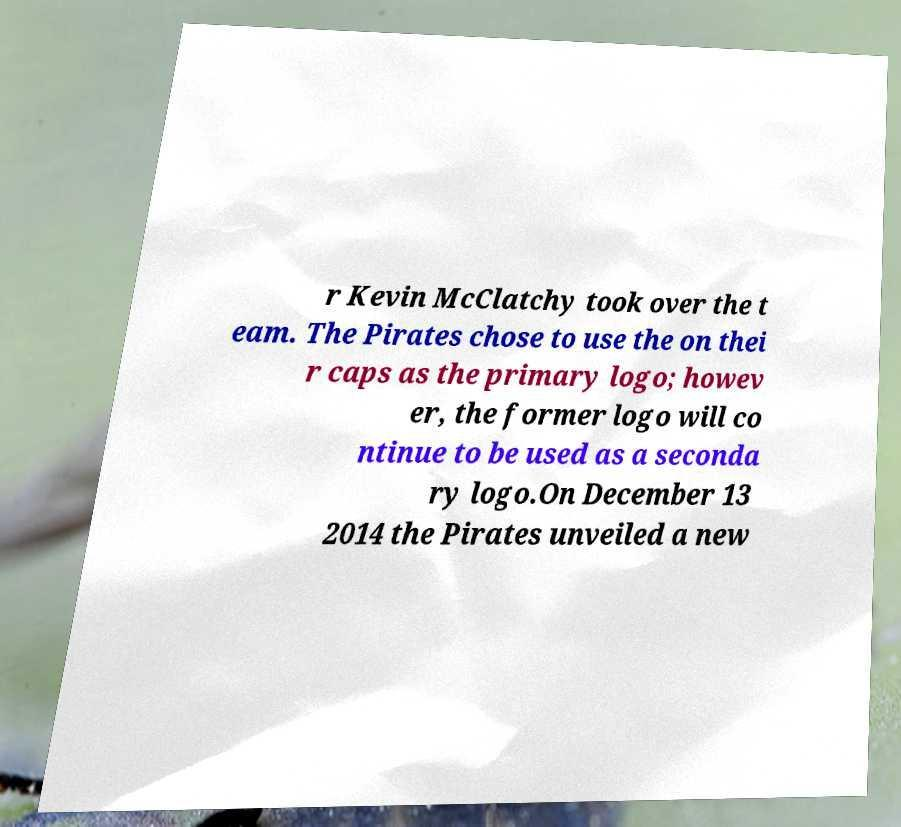Can you accurately transcribe the text from the provided image for me? r Kevin McClatchy took over the t eam. The Pirates chose to use the on thei r caps as the primary logo; howev er, the former logo will co ntinue to be used as a seconda ry logo.On December 13 2014 the Pirates unveiled a new 